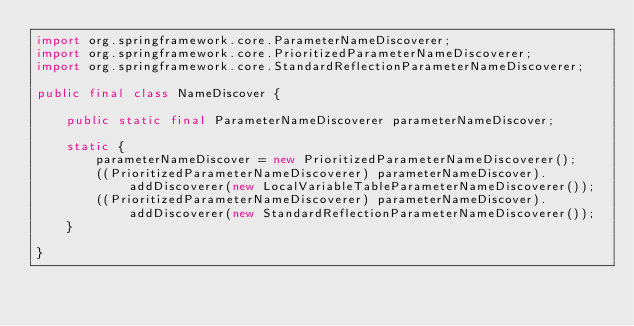Convert code to text. <code><loc_0><loc_0><loc_500><loc_500><_Java_>import org.springframework.core.ParameterNameDiscoverer;
import org.springframework.core.PrioritizedParameterNameDiscoverer;
import org.springframework.core.StandardReflectionParameterNameDiscoverer;

public final class NameDiscover {

    public static final ParameterNameDiscoverer parameterNameDiscover;

    static {
        parameterNameDiscover = new PrioritizedParameterNameDiscoverer();
        ((PrioritizedParameterNameDiscoverer) parameterNameDiscover).addDiscoverer(new LocalVariableTableParameterNameDiscoverer());
        ((PrioritizedParameterNameDiscoverer) parameterNameDiscover).addDiscoverer(new StandardReflectionParameterNameDiscoverer());
    }

}
</code> 